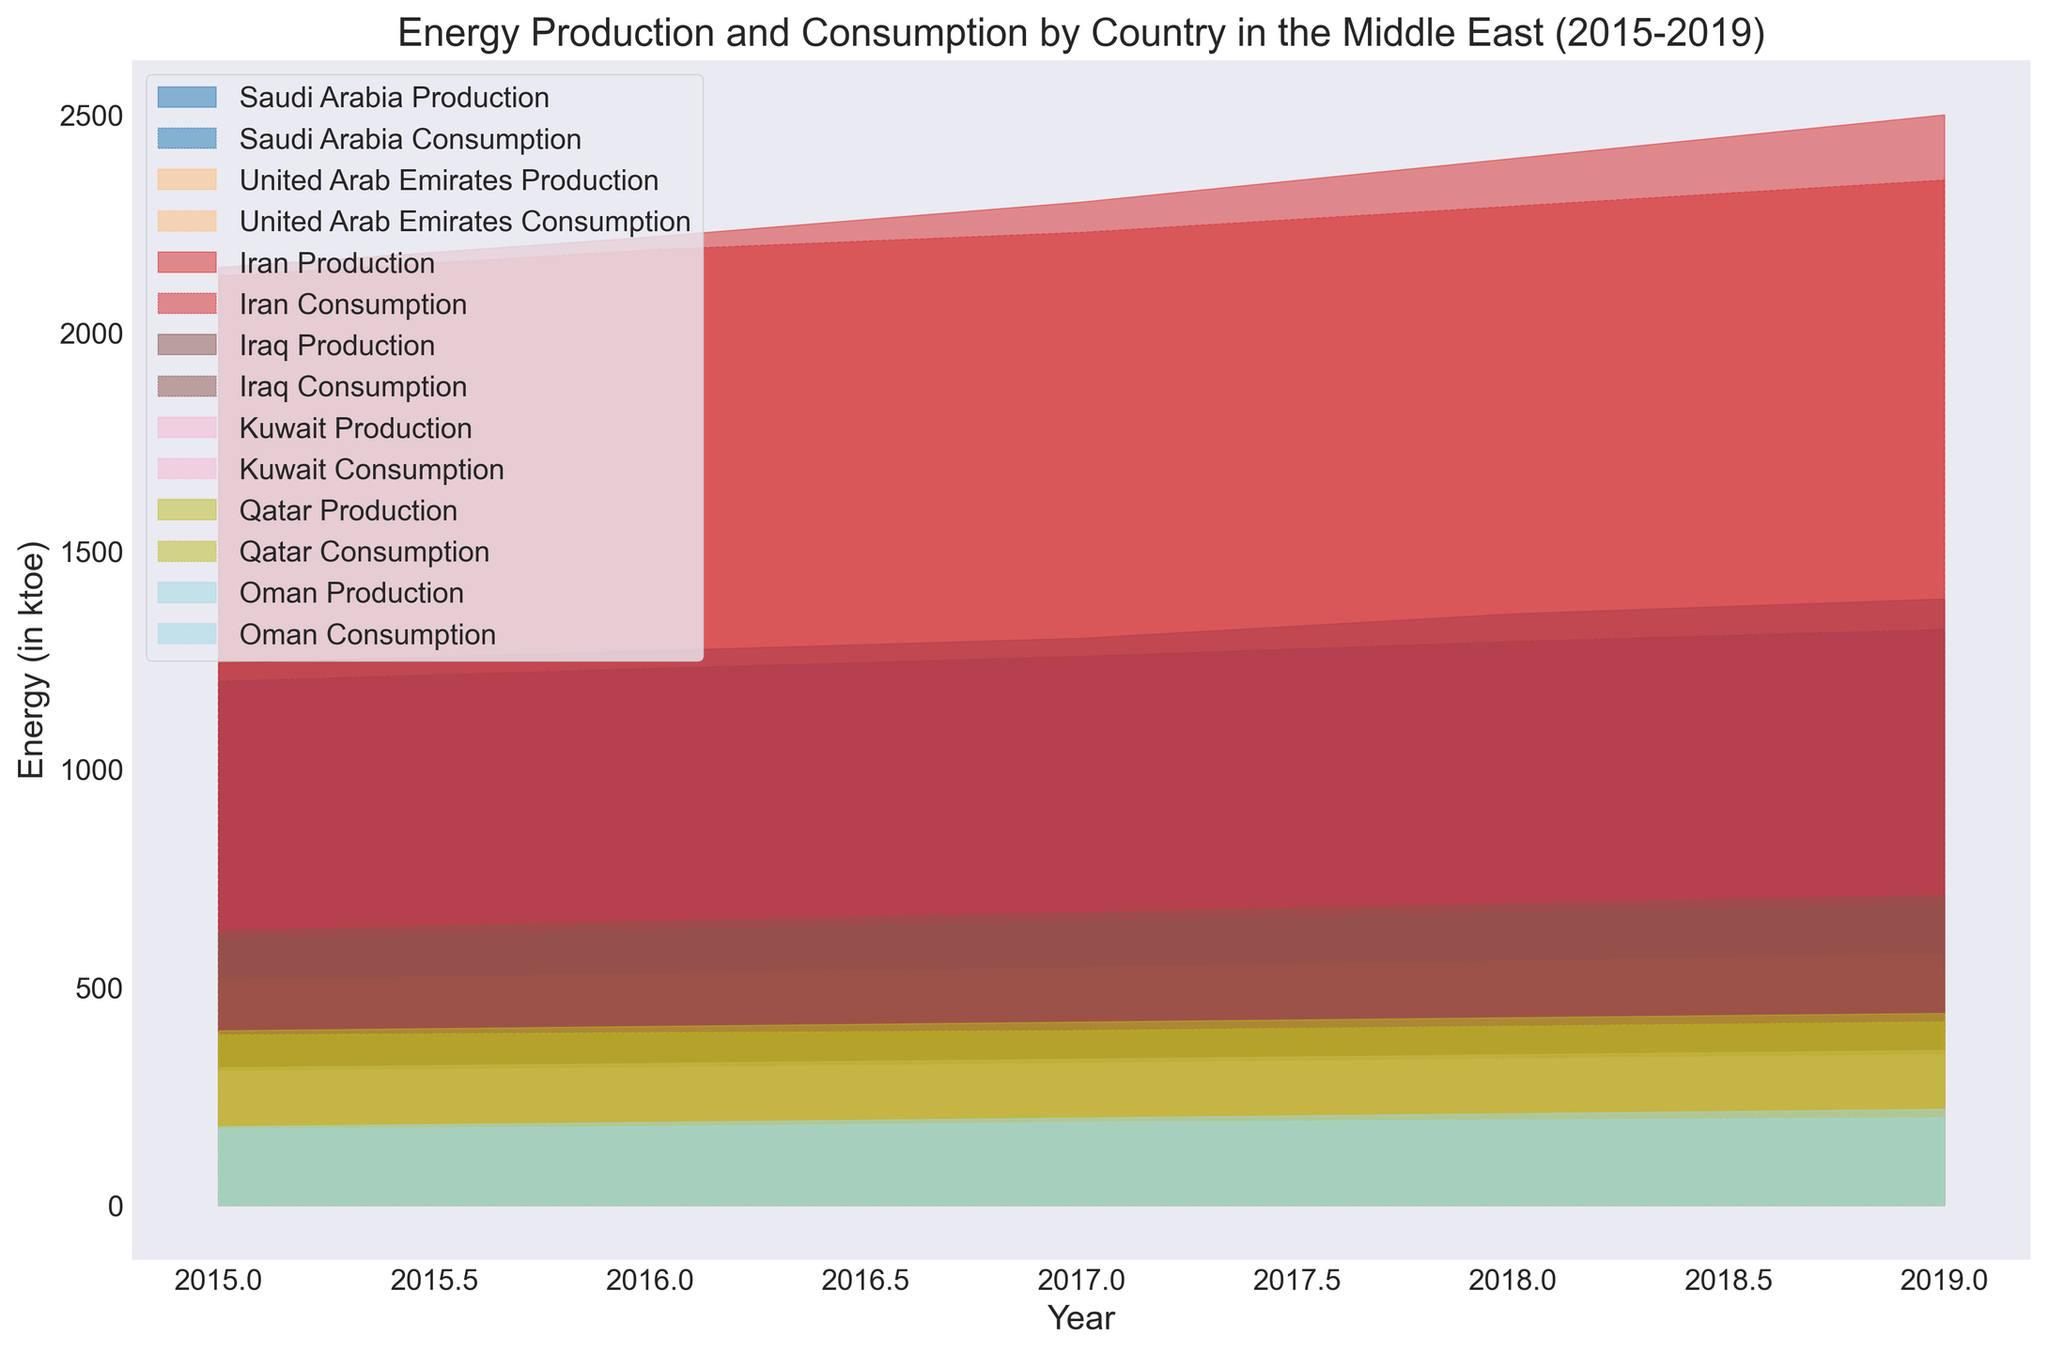What trend can be observed in energy production for Saudi Arabia from 2015 to 2019? Observing the area chart representing energy production for Saudi Arabia from 2015 to 2019, we can see an upward trend. The colored area representing Saudi Arabia's production increases consistently over these years.
Answer: Upward trend How does the energy consumption of the United Arab Emirates in 2019 compare to its energy production in the same year? By comparing the visual areas for production and consumption of the United Arab Emirates in 2019, we notice that the energy production area (higher) is greater than the energy consumption area (lower).
Answer: Greater Which country had the highest energy production in 2017? To determine this, compare the production levels for each country in 2017. Iran has the largest area shaded for energy production.
Answer: Iran What is the difference in energy consumption between Iran and Iraq in 2019? By looking at the energy consumption areas for Iran and Iraq in 2019, Iran’s consumption is higher. The numerical difference is observed between these points: 2350 (Iran) - 690 (Iraq).
Answer: 1660 Which country shows a stable energy production trend from 2015 to 2019? Evaluate the energy production areas for stability across all years. Qatar shows the most consistent (least varying) upward trend in energy production.
Answer: Qatar Compare the energy consumption trends between Saudi Arabia and Kuwait from 2015 to 2019. Saudi Arabia’s consumption shows a steady and steeper increase, while Kuwait’s consumption increases more gradually.
Answer: Steady and steeper (Saudi Arabia), Gradual (Kuwait) What is the average energy production for Oman from 2015 to 2019? Sum up the energy production values for Oman from 2015 to 2019, then divide by the number of years: (180 + 190 + 200 + 210 + 220) / 5.
Answer: 200 How does Iraq's energy consumption in 2019 compare to its energy production in 2019? Compare the respective areas for Iraq’s consumption and production in 2019. The production area is slightly higher than the consumption area.
Answer: Higher Which country had the smallest gap between energy production and consumption in 2017? Evaluate the visual gap between production and consumption for each country in 2017. Oman shows the smallest difference between the two areas.
Answer: Oman 